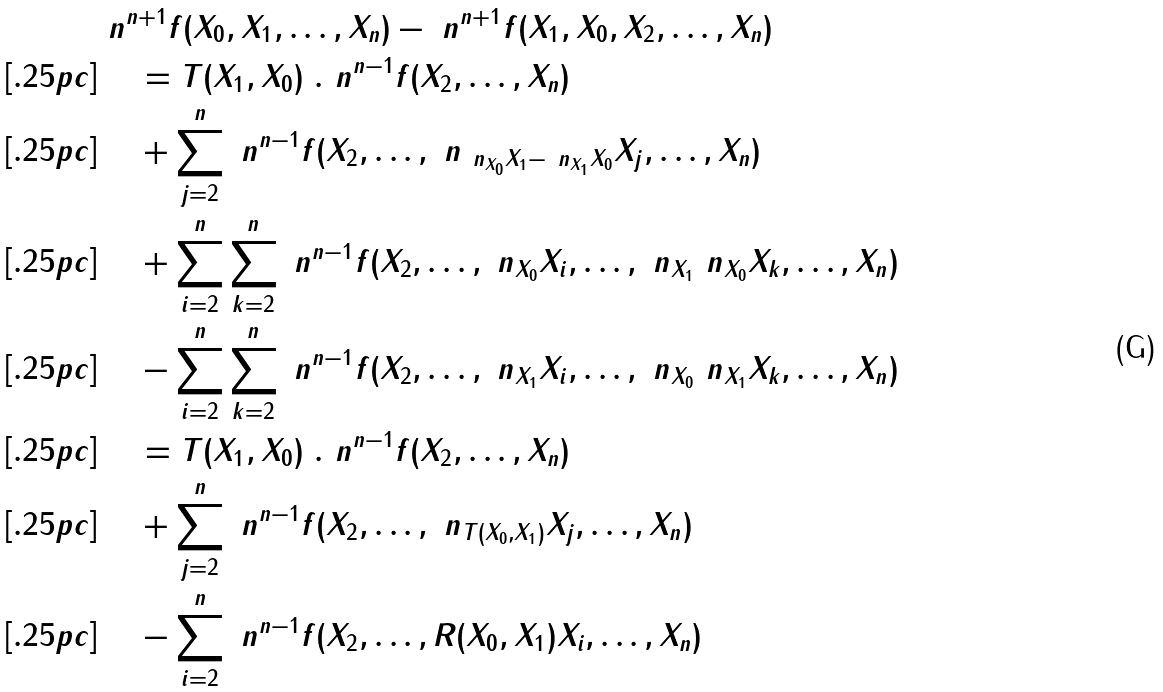Convert formula to latex. <formula><loc_0><loc_0><loc_500><loc_500>& \ n ^ { n + 1 } f ( X _ { 0 } , X _ { 1 } , \dots , X _ { n } ) - \ n ^ { n + 1 } f ( X _ { 1 } , X _ { 0 } , X _ { 2 } , \dots , X _ { n } ) \\ [ . 2 5 p c ] & \quad \, = T ( X _ { 1 } , X _ { 0 } ) \ . \ n ^ { n - 1 } f ( X _ { 2 } , \dots , X _ { n } ) \\ [ . 2 5 p c ] & \quad \, + \sum _ { j = 2 } ^ { n } \ n ^ { n - 1 } f ( X _ { 2 } , \dots , \ n _ { \ n _ { X _ { 0 } } X _ { 1 } - \ n _ { X _ { 1 } } X _ { 0 } } X _ { j } , \dots , X _ { n } ) \\ [ . 2 5 p c ] & \quad \, + \sum _ { i = 2 } ^ { n } \sum _ { k = 2 } ^ { n } \ n ^ { n - 1 } f ( X _ { 2 } , \dots , \ n _ { X _ { 0 } } X _ { i } , \dots , \ n _ { X _ { 1 } } \ n _ { X _ { 0 } } X _ { k } , \dots , X _ { n } ) \\ [ . 2 5 p c ] & \quad \, - \sum _ { i = 2 } ^ { n } \sum _ { k = 2 } ^ { n } \ n ^ { n - 1 } f ( X _ { 2 } , \dots , \ n _ { X _ { 1 } } X _ { i } , \dots , \ n _ { X _ { 0 } } \ n _ { X _ { 1 } } X _ { k } , \dots , X _ { n } ) \\ [ . 2 5 p c ] & \quad \, = T ( X _ { 1 } , X _ { 0 } ) \ . \ n ^ { n - 1 } f ( X _ { 2 } , \dots , X _ { n } ) \\ [ . 2 5 p c ] & \quad \, + \sum _ { j = 2 } ^ { n } \ n ^ { n - 1 } f ( X _ { 2 } , \dots , \ n _ { T ( X _ { 0 } , X _ { 1 } ) } X _ { j } , \dots , X _ { n } ) \\ [ . 2 5 p c ] & \quad \, - \sum _ { i = 2 } ^ { n } \ n ^ { n - 1 } f ( X _ { 2 } , \dots , R ( X _ { 0 } , X _ { 1 } ) X _ { i } , \dots , X _ { n } )</formula> 